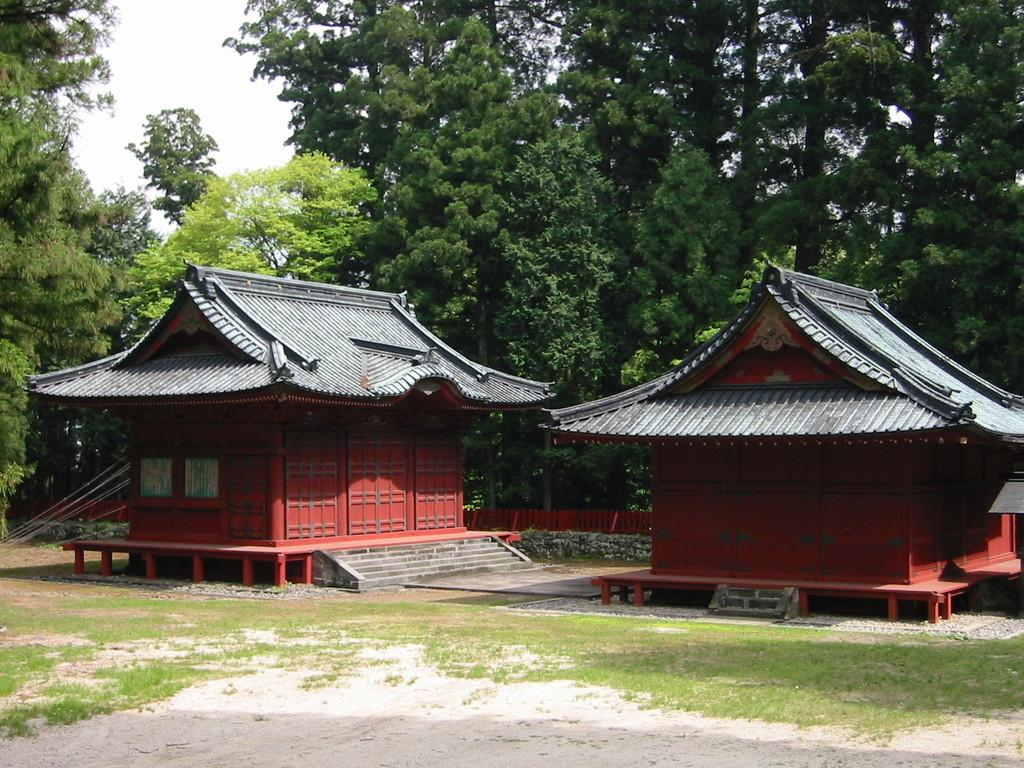How many buildings can be seen in the image? There are two buildings in the image. What type of surface is present on the floor? There is sand and grass on the floor. What type of vegetation is present in the image? There are trees in the image. What is the condition of the sky in the image? The sky is clear in the image. What type of apparel is being worn by the trees in the image? There are no people or apparel present in the image, only trees. Can you tell me how many eggnogs are visible in the image? There is no eggnog present in the image. 